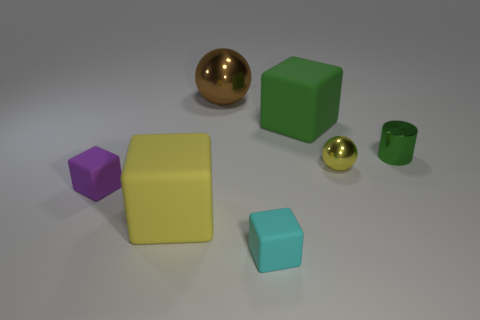Add 1 big things. How many objects exist? 8 Subtract all spheres. How many objects are left? 5 Add 5 cubes. How many cubes are left? 9 Add 4 yellow matte blocks. How many yellow matte blocks exist? 5 Subtract 1 yellow blocks. How many objects are left? 6 Subtract all blue shiny cylinders. Subtract all big matte cubes. How many objects are left? 5 